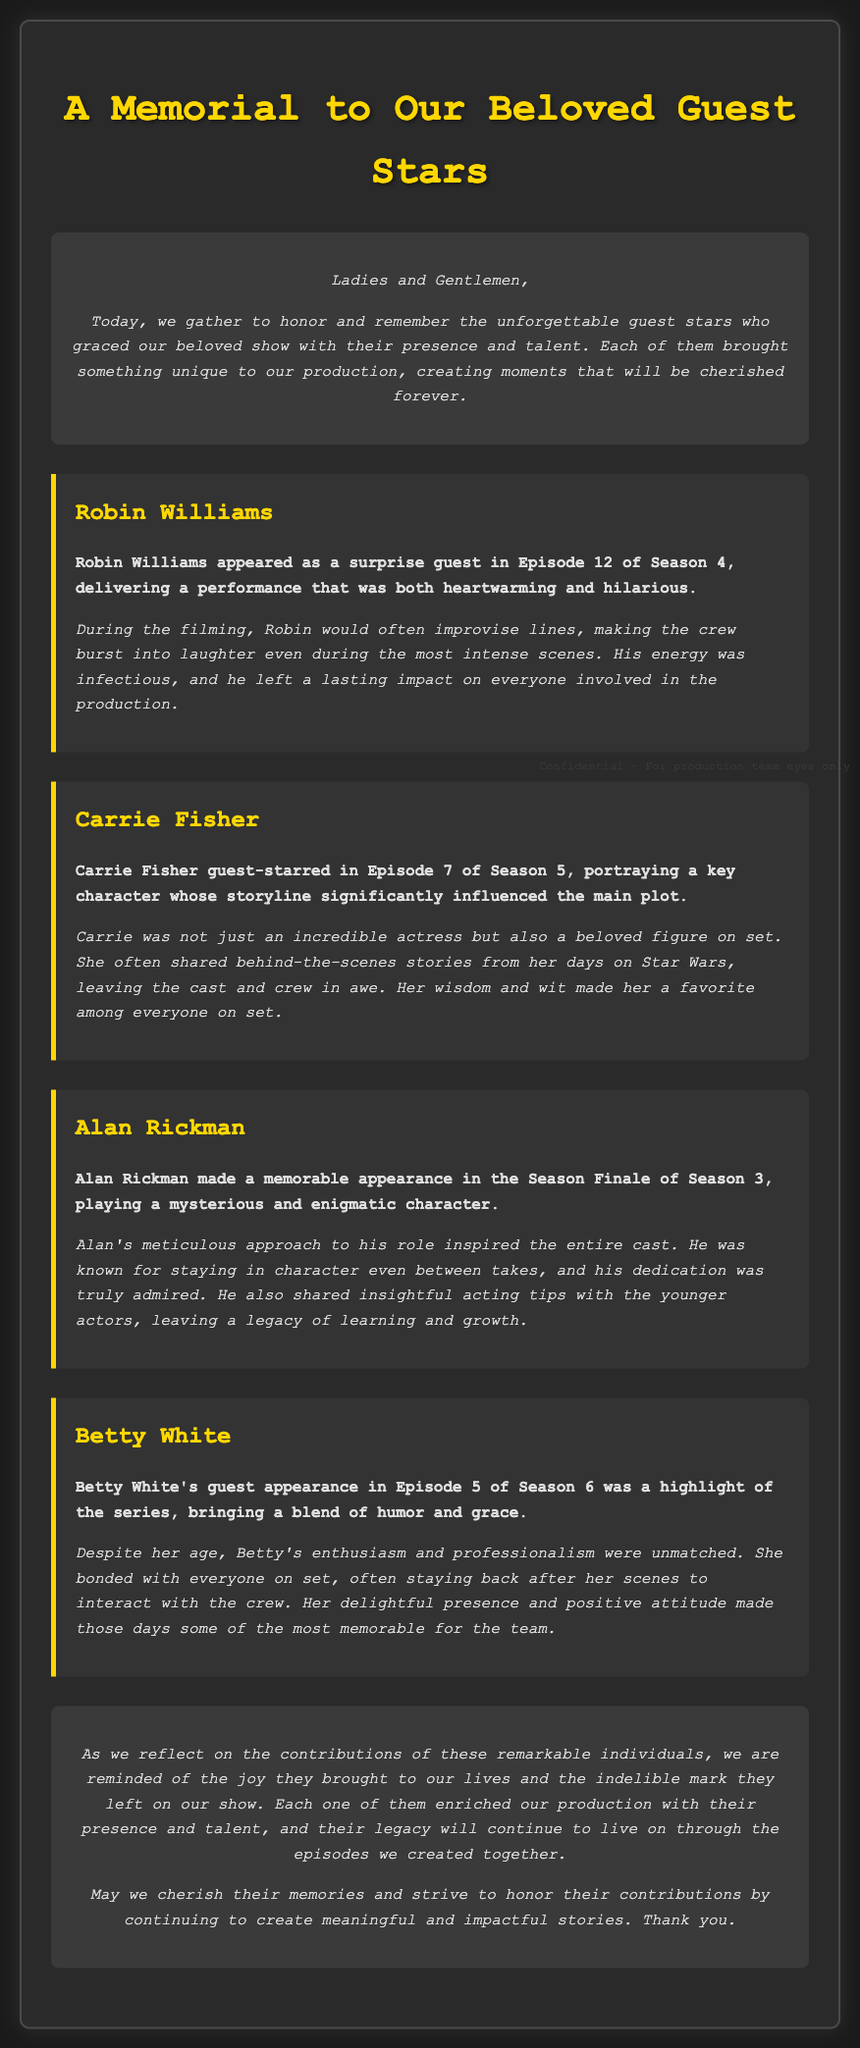What was the title of the document? The title is prominently displayed at the top of the document, indicating its purpose.
Answer: A Memorial to Our Beloved Guest Stars Who appeared in Episode 12 of Season 4? The document lists guest stars along with their respective episodes, revealing who appeared in that specific episode.
Answer: Robin Williams In which season did Carrie Fisher guest-star? The document states the season number where Carrie Fisher made her appearance, providing clear information for reference.
Answer: Season 5 What role did Alan Rickman play in the Season Finale of Season 3? Alan Rickman's guest appearance is described with an emphasis on his character's description within the document.
Answer: Mysterious and enigmatic character How did Betty White interact with the crew? The document gives insight into Betty White's behavior on set, illustrating her rapport with the team during her appearance.
Answer: Bonded with everyone on set What was Robin Williams known for during filming? The document provides specific anecdotes about each guest star, highlighting unique aspects of their contributions.
Answer: Improvising lines Why is Carrie Fisher remembered fondly by the crew? The details shared about Carrie Fisher's interactions and the impact of her stories on set help answer this question.
Answer: Wisdom and wit What is the overall theme of the document? The document serves to remember and celebrate the contributions of guest stars, captured in a reflective manner.
Answer: Honor and remembrance 